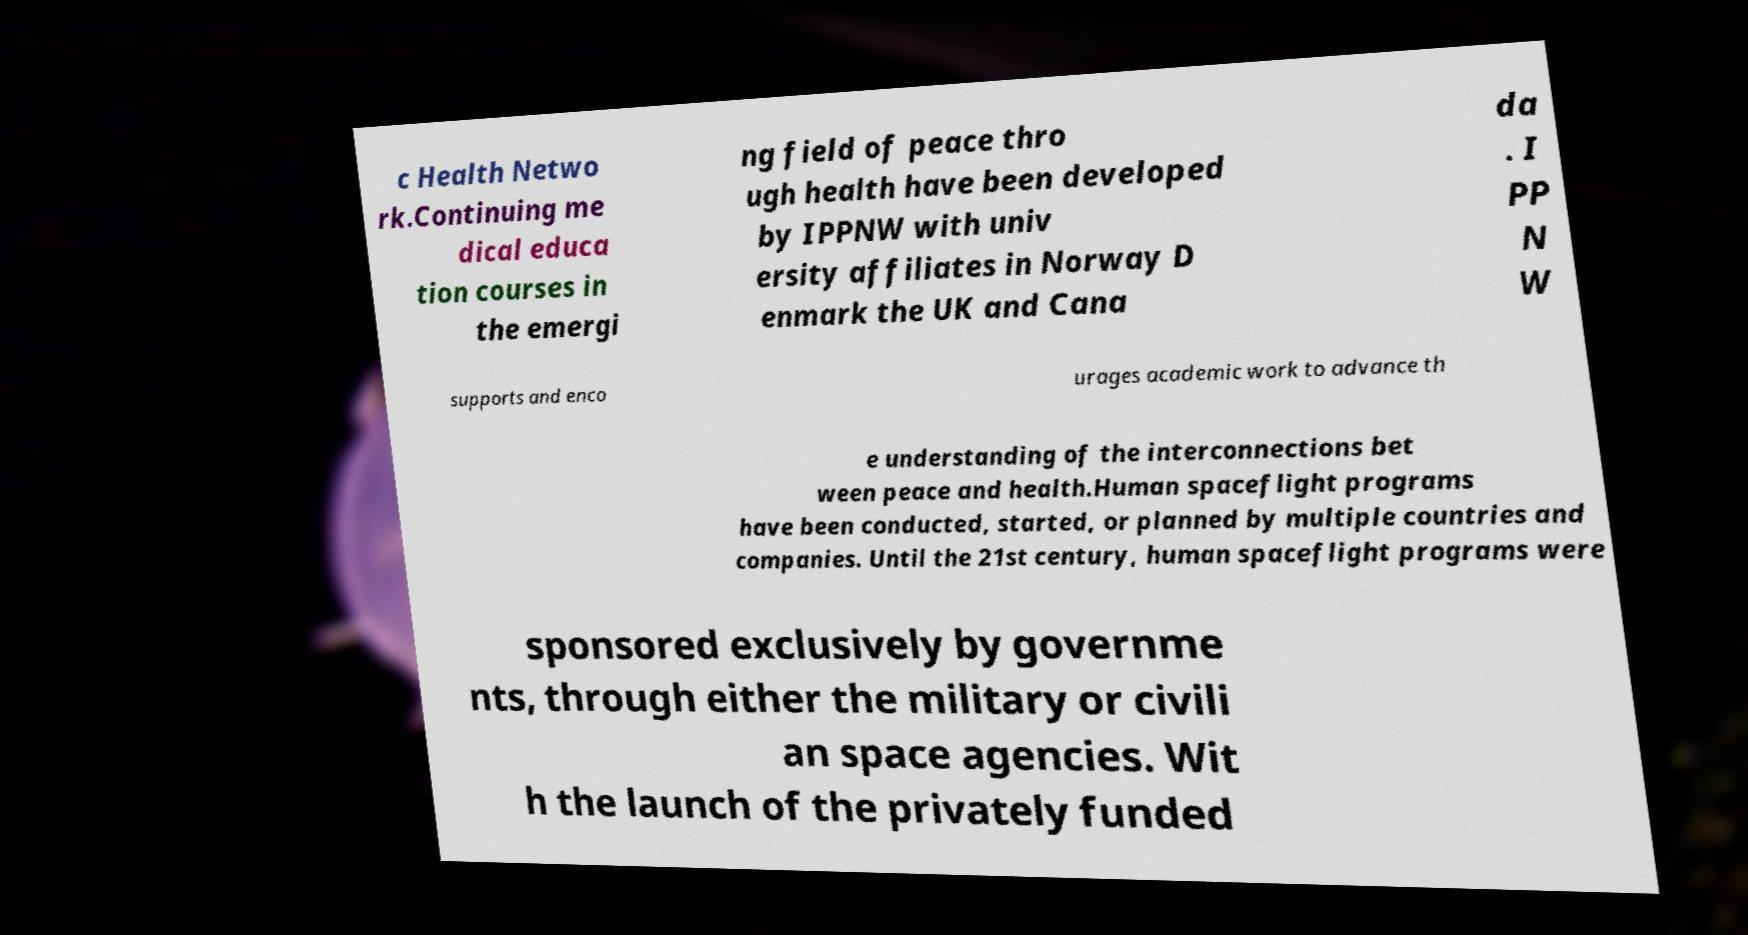I need the written content from this picture converted into text. Can you do that? c Health Netwo rk.Continuing me dical educa tion courses in the emergi ng field of peace thro ugh health have been developed by IPPNW with univ ersity affiliates in Norway D enmark the UK and Cana da . I PP N W supports and enco urages academic work to advance th e understanding of the interconnections bet ween peace and health.Human spaceflight programs have been conducted, started, or planned by multiple countries and companies. Until the 21st century, human spaceflight programs were sponsored exclusively by governme nts, through either the military or civili an space agencies. Wit h the launch of the privately funded 